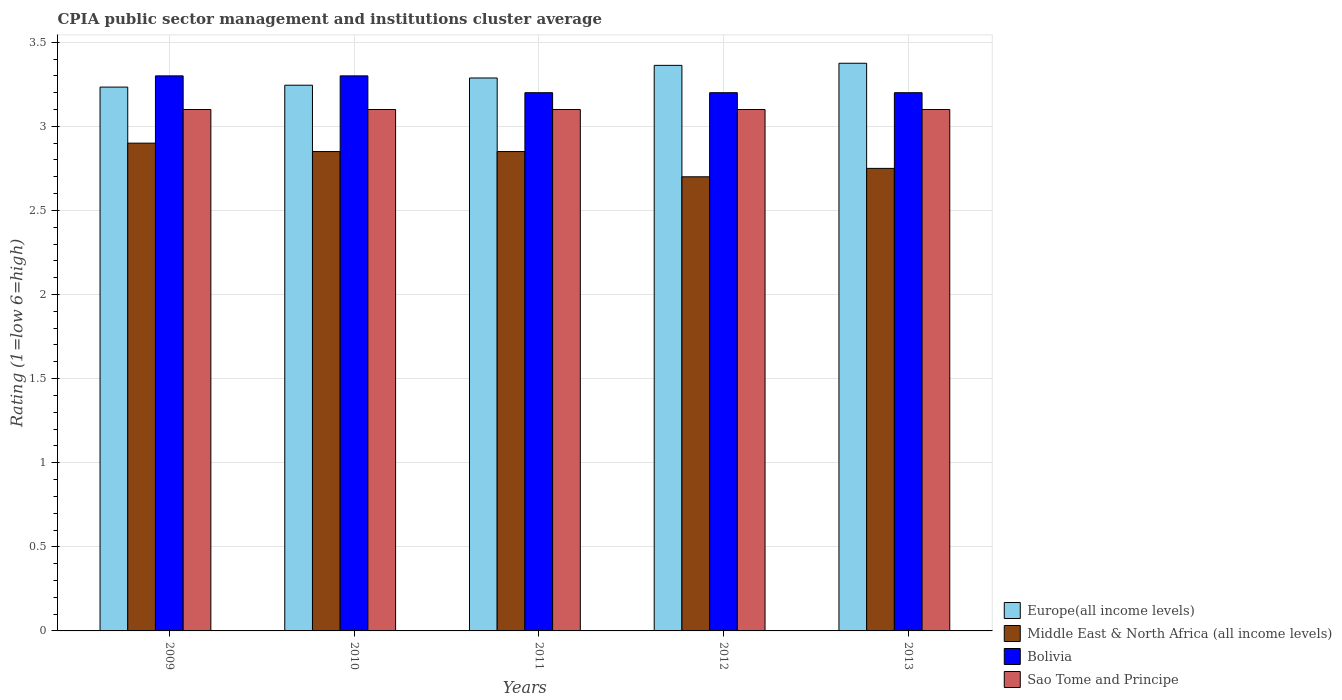How many different coloured bars are there?
Ensure brevity in your answer.  4. How many bars are there on the 1st tick from the left?
Offer a very short reply. 4. How many bars are there on the 5th tick from the right?
Give a very brief answer. 4. In how many cases, is the number of bars for a given year not equal to the number of legend labels?
Your answer should be very brief. 0. What is the CPIA rating in Middle East & North Africa (all income levels) in 2013?
Your answer should be very brief. 2.75. What is the total CPIA rating in Europe(all income levels) in the graph?
Your answer should be very brief. 16.5. What is the difference between the CPIA rating in Sao Tome and Principe in 2009 and that in 2012?
Keep it short and to the point. 0. What is the difference between the CPIA rating in Sao Tome and Principe in 2011 and the CPIA rating in Europe(all income levels) in 2012?
Make the answer very short. -0.26. What is the average CPIA rating in Europe(all income levels) per year?
Ensure brevity in your answer.  3.3. In the year 2009, what is the difference between the CPIA rating in Europe(all income levels) and CPIA rating in Middle East & North Africa (all income levels)?
Offer a terse response. 0.33. In how many years, is the CPIA rating in Sao Tome and Principe greater than 2.9?
Provide a short and direct response. 5. What is the ratio of the CPIA rating in Middle East & North Africa (all income levels) in 2010 to that in 2012?
Provide a succinct answer. 1.06. Is the difference between the CPIA rating in Europe(all income levels) in 2011 and 2012 greater than the difference between the CPIA rating in Middle East & North Africa (all income levels) in 2011 and 2012?
Provide a short and direct response. No. What is the difference between the highest and the lowest CPIA rating in Europe(all income levels)?
Provide a short and direct response. 0.14. In how many years, is the CPIA rating in Middle East & North Africa (all income levels) greater than the average CPIA rating in Middle East & North Africa (all income levels) taken over all years?
Give a very brief answer. 3. Is the sum of the CPIA rating in Middle East & North Africa (all income levels) in 2009 and 2012 greater than the maximum CPIA rating in Bolivia across all years?
Your response must be concise. Yes. What does the 4th bar from the left in 2012 represents?
Make the answer very short. Sao Tome and Principe. What does the 1st bar from the right in 2011 represents?
Make the answer very short. Sao Tome and Principe. How many bars are there?
Provide a short and direct response. 20. Are all the bars in the graph horizontal?
Provide a succinct answer. No. What is the difference between two consecutive major ticks on the Y-axis?
Your answer should be very brief. 0.5. Does the graph contain any zero values?
Provide a succinct answer. No. Does the graph contain grids?
Offer a terse response. Yes. Where does the legend appear in the graph?
Make the answer very short. Bottom right. How many legend labels are there?
Your answer should be compact. 4. What is the title of the graph?
Your answer should be very brief. CPIA public sector management and institutions cluster average. Does "Paraguay" appear as one of the legend labels in the graph?
Ensure brevity in your answer.  No. What is the label or title of the Y-axis?
Give a very brief answer. Rating (1=low 6=high). What is the Rating (1=low 6=high) in Europe(all income levels) in 2009?
Offer a terse response. 3.23. What is the Rating (1=low 6=high) of Bolivia in 2009?
Keep it short and to the point. 3.3. What is the Rating (1=low 6=high) in Europe(all income levels) in 2010?
Make the answer very short. 3.24. What is the Rating (1=low 6=high) of Middle East & North Africa (all income levels) in 2010?
Give a very brief answer. 2.85. What is the Rating (1=low 6=high) of Europe(all income levels) in 2011?
Provide a short and direct response. 3.29. What is the Rating (1=low 6=high) of Middle East & North Africa (all income levels) in 2011?
Provide a short and direct response. 2.85. What is the Rating (1=low 6=high) in Bolivia in 2011?
Your answer should be compact. 3.2. What is the Rating (1=low 6=high) in Europe(all income levels) in 2012?
Make the answer very short. 3.36. What is the Rating (1=low 6=high) of Middle East & North Africa (all income levels) in 2012?
Your response must be concise. 2.7. What is the Rating (1=low 6=high) of Sao Tome and Principe in 2012?
Ensure brevity in your answer.  3.1. What is the Rating (1=low 6=high) of Europe(all income levels) in 2013?
Your answer should be very brief. 3.38. What is the Rating (1=low 6=high) of Middle East & North Africa (all income levels) in 2013?
Make the answer very short. 2.75. What is the Rating (1=low 6=high) of Sao Tome and Principe in 2013?
Your response must be concise. 3.1. Across all years, what is the maximum Rating (1=low 6=high) in Europe(all income levels)?
Give a very brief answer. 3.38. Across all years, what is the maximum Rating (1=low 6=high) of Middle East & North Africa (all income levels)?
Offer a very short reply. 2.9. Across all years, what is the minimum Rating (1=low 6=high) of Europe(all income levels)?
Give a very brief answer. 3.23. What is the total Rating (1=low 6=high) in Europe(all income levels) in the graph?
Offer a terse response. 16.5. What is the total Rating (1=low 6=high) in Middle East & North Africa (all income levels) in the graph?
Offer a terse response. 14.05. What is the total Rating (1=low 6=high) of Sao Tome and Principe in the graph?
Provide a short and direct response. 15.5. What is the difference between the Rating (1=low 6=high) of Europe(all income levels) in 2009 and that in 2010?
Your response must be concise. -0.01. What is the difference between the Rating (1=low 6=high) of Middle East & North Africa (all income levels) in 2009 and that in 2010?
Provide a short and direct response. 0.05. What is the difference between the Rating (1=low 6=high) of Bolivia in 2009 and that in 2010?
Keep it short and to the point. 0. What is the difference between the Rating (1=low 6=high) in Sao Tome and Principe in 2009 and that in 2010?
Provide a short and direct response. 0. What is the difference between the Rating (1=low 6=high) of Europe(all income levels) in 2009 and that in 2011?
Make the answer very short. -0.05. What is the difference between the Rating (1=low 6=high) in Middle East & North Africa (all income levels) in 2009 and that in 2011?
Give a very brief answer. 0.05. What is the difference between the Rating (1=low 6=high) in Europe(all income levels) in 2009 and that in 2012?
Your response must be concise. -0.13. What is the difference between the Rating (1=low 6=high) of Bolivia in 2009 and that in 2012?
Make the answer very short. 0.1. What is the difference between the Rating (1=low 6=high) in Europe(all income levels) in 2009 and that in 2013?
Provide a short and direct response. -0.14. What is the difference between the Rating (1=low 6=high) of Middle East & North Africa (all income levels) in 2009 and that in 2013?
Provide a short and direct response. 0.15. What is the difference between the Rating (1=low 6=high) in Sao Tome and Principe in 2009 and that in 2013?
Ensure brevity in your answer.  0. What is the difference between the Rating (1=low 6=high) in Europe(all income levels) in 2010 and that in 2011?
Your response must be concise. -0.04. What is the difference between the Rating (1=low 6=high) of Bolivia in 2010 and that in 2011?
Your response must be concise. 0.1. What is the difference between the Rating (1=low 6=high) of Europe(all income levels) in 2010 and that in 2012?
Your answer should be very brief. -0.12. What is the difference between the Rating (1=low 6=high) in Middle East & North Africa (all income levels) in 2010 and that in 2012?
Offer a terse response. 0.15. What is the difference between the Rating (1=low 6=high) in Europe(all income levels) in 2010 and that in 2013?
Provide a short and direct response. -0.13. What is the difference between the Rating (1=low 6=high) of Middle East & North Africa (all income levels) in 2010 and that in 2013?
Make the answer very short. 0.1. What is the difference between the Rating (1=low 6=high) in Europe(all income levels) in 2011 and that in 2012?
Provide a succinct answer. -0.07. What is the difference between the Rating (1=low 6=high) in Bolivia in 2011 and that in 2012?
Your answer should be compact. 0. What is the difference between the Rating (1=low 6=high) in Europe(all income levels) in 2011 and that in 2013?
Keep it short and to the point. -0.09. What is the difference between the Rating (1=low 6=high) of Middle East & North Africa (all income levels) in 2011 and that in 2013?
Give a very brief answer. 0.1. What is the difference between the Rating (1=low 6=high) of Bolivia in 2011 and that in 2013?
Your answer should be very brief. 0. What is the difference between the Rating (1=low 6=high) in Europe(all income levels) in 2012 and that in 2013?
Offer a very short reply. -0.01. What is the difference between the Rating (1=low 6=high) of Middle East & North Africa (all income levels) in 2012 and that in 2013?
Your response must be concise. -0.05. What is the difference between the Rating (1=low 6=high) of Sao Tome and Principe in 2012 and that in 2013?
Make the answer very short. 0. What is the difference between the Rating (1=low 6=high) of Europe(all income levels) in 2009 and the Rating (1=low 6=high) of Middle East & North Africa (all income levels) in 2010?
Make the answer very short. 0.38. What is the difference between the Rating (1=low 6=high) in Europe(all income levels) in 2009 and the Rating (1=low 6=high) in Bolivia in 2010?
Keep it short and to the point. -0.07. What is the difference between the Rating (1=low 6=high) in Europe(all income levels) in 2009 and the Rating (1=low 6=high) in Sao Tome and Principe in 2010?
Give a very brief answer. 0.13. What is the difference between the Rating (1=low 6=high) in Middle East & North Africa (all income levels) in 2009 and the Rating (1=low 6=high) in Bolivia in 2010?
Provide a succinct answer. -0.4. What is the difference between the Rating (1=low 6=high) of Europe(all income levels) in 2009 and the Rating (1=low 6=high) of Middle East & North Africa (all income levels) in 2011?
Your answer should be very brief. 0.38. What is the difference between the Rating (1=low 6=high) of Europe(all income levels) in 2009 and the Rating (1=low 6=high) of Bolivia in 2011?
Ensure brevity in your answer.  0.03. What is the difference between the Rating (1=low 6=high) of Europe(all income levels) in 2009 and the Rating (1=low 6=high) of Sao Tome and Principe in 2011?
Ensure brevity in your answer.  0.13. What is the difference between the Rating (1=low 6=high) in Middle East & North Africa (all income levels) in 2009 and the Rating (1=low 6=high) in Bolivia in 2011?
Your answer should be compact. -0.3. What is the difference between the Rating (1=low 6=high) of Europe(all income levels) in 2009 and the Rating (1=low 6=high) of Middle East & North Africa (all income levels) in 2012?
Keep it short and to the point. 0.53. What is the difference between the Rating (1=low 6=high) in Europe(all income levels) in 2009 and the Rating (1=low 6=high) in Sao Tome and Principe in 2012?
Provide a succinct answer. 0.13. What is the difference between the Rating (1=low 6=high) in Bolivia in 2009 and the Rating (1=low 6=high) in Sao Tome and Principe in 2012?
Provide a short and direct response. 0.2. What is the difference between the Rating (1=low 6=high) of Europe(all income levels) in 2009 and the Rating (1=low 6=high) of Middle East & North Africa (all income levels) in 2013?
Offer a terse response. 0.48. What is the difference between the Rating (1=low 6=high) in Europe(all income levels) in 2009 and the Rating (1=low 6=high) in Sao Tome and Principe in 2013?
Offer a terse response. 0.13. What is the difference between the Rating (1=low 6=high) in Bolivia in 2009 and the Rating (1=low 6=high) in Sao Tome and Principe in 2013?
Give a very brief answer. 0.2. What is the difference between the Rating (1=low 6=high) in Europe(all income levels) in 2010 and the Rating (1=low 6=high) in Middle East & North Africa (all income levels) in 2011?
Offer a terse response. 0.39. What is the difference between the Rating (1=low 6=high) of Europe(all income levels) in 2010 and the Rating (1=low 6=high) of Bolivia in 2011?
Your response must be concise. 0.04. What is the difference between the Rating (1=low 6=high) of Europe(all income levels) in 2010 and the Rating (1=low 6=high) of Sao Tome and Principe in 2011?
Keep it short and to the point. 0.14. What is the difference between the Rating (1=low 6=high) in Middle East & North Africa (all income levels) in 2010 and the Rating (1=low 6=high) in Bolivia in 2011?
Give a very brief answer. -0.35. What is the difference between the Rating (1=low 6=high) of Middle East & North Africa (all income levels) in 2010 and the Rating (1=low 6=high) of Sao Tome and Principe in 2011?
Offer a terse response. -0.25. What is the difference between the Rating (1=low 6=high) in Europe(all income levels) in 2010 and the Rating (1=low 6=high) in Middle East & North Africa (all income levels) in 2012?
Ensure brevity in your answer.  0.54. What is the difference between the Rating (1=low 6=high) in Europe(all income levels) in 2010 and the Rating (1=low 6=high) in Bolivia in 2012?
Your response must be concise. 0.04. What is the difference between the Rating (1=low 6=high) in Europe(all income levels) in 2010 and the Rating (1=low 6=high) in Sao Tome and Principe in 2012?
Offer a terse response. 0.14. What is the difference between the Rating (1=low 6=high) in Middle East & North Africa (all income levels) in 2010 and the Rating (1=low 6=high) in Bolivia in 2012?
Offer a very short reply. -0.35. What is the difference between the Rating (1=low 6=high) in Middle East & North Africa (all income levels) in 2010 and the Rating (1=low 6=high) in Sao Tome and Principe in 2012?
Keep it short and to the point. -0.25. What is the difference between the Rating (1=low 6=high) in Europe(all income levels) in 2010 and the Rating (1=low 6=high) in Middle East & North Africa (all income levels) in 2013?
Keep it short and to the point. 0.49. What is the difference between the Rating (1=low 6=high) in Europe(all income levels) in 2010 and the Rating (1=low 6=high) in Bolivia in 2013?
Provide a succinct answer. 0.04. What is the difference between the Rating (1=low 6=high) in Europe(all income levels) in 2010 and the Rating (1=low 6=high) in Sao Tome and Principe in 2013?
Your answer should be very brief. 0.14. What is the difference between the Rating (1=low 6=high) of Middle East & North Africa (all income levels) in 2010 and the Rating (1=low 6=high) of Bolivia in 2013?
Provide a succinct answer. -0.35. What is the difference between the Rating (1=low 6=high) in Middle East & North Africa (all income levels) in 2010 and the Rating (1=low 6=high) in Sao Tome and Principe in 2013?
Offer a very short reply. -0.25. What is the difference between the Rating (1=low 6=high) of Europe(all income levels) in 2011 and the Rating (1=low 6=high) of Middle East & North Africa (all income levels) in 2012?
Offer a very short reply. 0.59. What is the difference between the Rating (1=low 6=high) in Europe(all income levels) in 2011 and the Rating (1=low 6=high) in Bolivia in 2012?
Your response must be concise. 0.09. What is the difference between the Rating (1=low 6=high) of Europe(all income levels) in 2011 and the Rating (1=low 6=high) of Sao Tome and Principe in 2012?
Keep it short and to the point. 0.19. What is the difference between the Rating (1=low 6=high) in Middle East & North Africa (all income levels) in 2011 and the Rating (1=low 6=high) in Bolivia in 2012?
Provide a succinct answer. -0.35. What is the difference between the Rating (1=low 6=high) in Bolivia in 2011 and the Rating (1=low 6=high) in Sao Tome and Principe in 2012?
Keep it short and to the point. 0.1. What is the difference between the Rating (1=low 6=high) in Europe(all income levels) in 2011 and the Rating (1=low 6=high) in Middle East & North Africa (all income levels) in 2013?
Provide a succinct answer. 0.54. What is the difference between the Rating (1=low 6=high) in Europe(all income levels) in 2011 and the Rating (1=low 6=high) in Bolivia in 2013?
Give a very brief answer. 0.09. What is the difference between the Rating (1=low 6=high) in Europe(all income levels) in 2011 and the Rating (1=low 6=high) in Sao Tome and Principe in 2013?
Your answer should be compact. 0.19. What is the difference between the Rating (1=low 6=high) in Middle East & North Africa (all income levels) in 2011 and the Rating (1=low 6=high) in Bolivia in 2013?
Your response must be concise. -0.35. What is the difference between the Rating (1=low 6=high) of Europe(all income levels) in 2012 and the Rating (1=low 6=high) of Middle East & North Africa (all income levels) in 2013?
Keep it short and to the point. 0.61. What is the difference between the Rating (1=low 6=high) in Europe(all income levels) in 2012 and the Rating (1=low 6=high) in Bolivia in 2013?
Provide a short and direct response. 0.16. What is the difference between the Rating (1=low 6=high) of Europe(all income levels) in 2012 and the Rating (1=low 6=high) of Sao Tome and Principe in 2013?
Your answer should be compact. 0.26. What is the difference between the Rating (1=low 6=high) in Middle East & North Africa (all income levels) in 2012 and the Rating (1=low 6=high) in Bolivia in 2013?
Provide a short and direct response. -0.5. What is the difference between the Rating (1=low 6=high) in Middle East & North Africa (all income levels) in 2012 and the Rating (1=low 6=high) in Sao Tome and Principe in 2013?
Your answer should be compact. -0.4. What is the difference between the Rating (1=low 6=high) of Bolivia in 2012 and the Rating (1=low 6=high) of Sao Tome and Principe in 2013?
Offer a terse response. 0.1. What is the average Rating (1=low 6=high) in Europe(all income levels) per year?
Offer a terse response. 3.3. What is the average Rating (1=low 6=high) of Middle East & North Africa (all income levels) per year?
Ensure brevity in your answer.  2.81. What is the average Rating (1=low 6=high) in Bolivia per year?
Provide a short and direct response. 3.24. In the year 2009, what is the difference between the Rating (1=low 6=high) of Europe(all income levels) and Rating (1=low 6=high) of Bolivia?
Provide a short and direct response. -0.07. In the year 2009, what is the difference between the Rating (1=low 6=high) of Europe(all income levels) and Rating (1=low 6=high) of Sao Tome and Principe?
Make the answer very short. 0.13. In the year 2009, what is the difference between the Rating (1=low 6=high) in Middle East & North Africa (all income levels) and Rating (1=low 6=high) in Bolivia?
Offer a very short reply. -0.4. In the year 2009, what is the difference between the Rating (1=low 6=high) in Bolivia and Rating (1=low 6=high) in Sao Tome and Principe?
Ensure brevity in your answer.  0.2. In the year 2010, what is the difference between the Rating (1=low 6=high) of Europe(all income levels) and Rating (1=low 6=high) of Middle East & North Africa (all income levels)?
Offer a terse response. 0.39. In the year 2010, what is the difference between the Rating (1=low 6=high) in Europe(all income levels) and Rating (1=low 6=high) in Bolivia?
Offer a very short reply. -0.06. In the year 2010, what is the difference between the Rating (1=low 6=high) in Europe(all income levels) and Rating (1=low 6=high) in Sao Tome and Principe?
Make the answer very short. 0.14. In the year 2010, what is the difference between the Rating (1=low 6=high) of Middle East & North Africa (all income levels) and Rating (1=low 6=high) of Bolivia?
Ensure brevity in your answer.  -0.45. In the year 2011, what is the difference between the Rating (1=low 6=high) of Europe(all income levels) and Rating (1=low 6=high) of Middle East & North Africa (all income levels)?
Keep it short and to the point. 0.44. In the year 2011, what is the difference between the Rating (1=low 6=high) in Europe(all income levels) and Rating (1=low 6=high) in Bolivia?
Your response must be concise. 0.09. In the year 2011, what is the difference between the Rating (1=low 6=high) of Europe(all income levels) and Rating (1=low 6=high) of Sao Tome and Principe?
Your answer should be very brief. 0.19. In the year 2011, what is the difference between the Rating (1=low 6=high) in Middle East & North Africa (all income levels) and Rating (1=low 6=high) in Bolivia?
Provide a succinct answer. -0.35. In the year 2011, what is the difference between the Rating (1=low 6=high) in Middle East & North Africa (all income levels) and Rating (1=low 6=high) in Sao Tome and Principe?
Offer a terse response. -0.25. In the year 2011, what is the difference between the Rating (1=low 6=high) in Bolivia and Rating (1=low 6=high) in Sao Tome and Principe?
Your answer should be very brief. 0.1. In the year 2012, what is the difference between the Rating (1=low 6=high) of Europe(all income levels) and Rating (1=low 6=high) of Middle East & North Africa (all income levels)?
Offer a terse response. 0.66. In the year 2012, what is the difference between the Rating (1=low 6=high) of Europe(all income levels) and Rating (1=low 6=high) of Bolivia?
Ensure brevity in your answer.  0.16. In the year 2012, what is the difference between the Rating (1=low 6=high) of Europe(all income levels) and Rating (1=low 6=high) of Sao Tome and Principe?
Your response must be concise. 0.26. In the year 2012, what is the difference between the Rating (1=low 6=high) in Bolivia and Rating (1=low 6=high) in Sao Tome and Principe?
Offer a very short reply. 0.1. In the year 2013, what is the difference between the Rating (1=low 6=high) of Europe(all income levels) and Rating (1=low 6=high) of Bolivia?
Provide a short and direct response. 0.17. In the year 2013, what is the difference between the Rating (1=low 6=high) of Europe(all income levels) and Rating (1=low 6=high) of Sao Tome and Principe?
Ensure brevity in your answer.  0.28. In the year 2013, what is the difference between the Rating (1=low 6=high) in Middle East & North Africa (all income levels) and Rating (1=low 6=high) in Bolivia?
Give a very brief answer. -0.45. In the year 2013, what is the difference between the Rating (1=low 6=high) in Middle East & North Africa (all income levels) and Rating (1=low 6=high) in Sao Tome and Principe?
Give a very brief answer. -0.35. What is the ratio of the Rating (1=low 6=high) in Middle East & North Africa (all income levels) in 2009 to that in 2010?
Provide a succinct answer. 1.02. What is the ratio of the Rating (1=low 6=high) of Bolivia in 2009 to that in 2010?
Give a very brief answer. 1. What is the ratio of the Rating (1=low 6=high) of Sao Tome and Principe in 2009 to that in 2010?
Your answer should be compact. 1. What is the ratio of the Rating (1=low 6=high) in Europe(all income levels) in 2009 to that in 2011?
Your answer should be compact. 0.98. What is the ratio of the Rating (1=low 6=high) in Middle East & North Africa (all income levels) in 2009 to that in 2011?
Give a very brief answer. 1.02. What is the ratio of the Rating (1=low 6=high) in Bolivia in 2009 to that in 2011?
Your answer should be compact. 1.03. What is the ratio of the Rating (1=low 6=high) in Sao Tome and Principe in 2009 to that in 2011?
Your response must be concise. 1. What is the ratio of the Rating (1=low 6=high) in Europe(all income levels) in 2009 to that in 2012?
Offer a very short reply. 0.96. What is the ratio of the Rating (1=low 6=high) of Middle East & North Africa (all income levels) in 2009 to that in 2012?
Offer a terse response. 1.07. What is the ratio of the Rating (1=low 6=high) in Bolivia in 2009 to that in 2012?
Give a very brief answer. 1.03. What is the ratio of the Rating (1=low 6=high) in Europe(all income levels) in 2009 to that in 2013?
Ensure brevity in your answer.  0.96. What is the ratio of the Rating (1=low 6=high) of Middle East & North Africa (all income levels) in 2009 to that in 2013?
Your answer should be compact. 1.05. What is the ratio of the Rating (1=low 6=high) in Bolivia in 2009 to that in 2013?
Your answer should be very brief. 1.03. What is the ratio of the Rating (1=low 6=high) of Sao Tome and Principe in 2009 to that in 2013?
Give a very brief answer. 1. What is the ratio of the Rating (1=low 6=high) of Europe(all income levels) in 2010 to that in 2011?
Give a very brief answer. 0.99. What is the ratio of the Rating (1=low 6=high) in Middle East & North Africa (all income levels) in 2010 to that in 2011?
Give a very brief answer. 1. What is the ratio of the Rating (1=low 6=high) in Bolivia in 2010 to that in 2011?
Give a very brief answer. 1.03. What is the ratio of the Rating (1=low 6=high) in Europe(all income levels) in 2010 to that in 2012?
Give a very brief answer. 0.96. What is the ratio of the Rating (1=low 6=high) of Middle East & North Africa (all income levels) in 2010 to that in 2012?
Your answer should be very brief. 1.06. What is the ratio of the Rating (1=low 6=high) in Bolivia in 2010 to that in 2012?
Offer a terse response. 1.03. What is the ratio of the Rating (1=low 6=high) in Europe(all income levels) in 2010 to that in 2013?
Offer a terse response. 0.96. What is the ratio of the Rating (1=low 6=high) in Middle East & North Africa (all income levels) in 2010 to that in 2013?
Your answer should be compact. 1.04. What is the ratio of the Rating (1=low 6=high) of Bolivia in 2010 to that in 2013?
Offer a very short reply. 1.03. What is the ratio of the Rating (1=low 6=high) of Sao Tome and Principe in 2010 to that in 2013?
Provide a short and direct response. 1. What is the ratio of the Rating (1=low 6=high) of Europe(all income levels) in 2011 to that in 2012?
Provide a short and direct response. 0.98. What is the ratio of the Rating (1=low 6=high) of Middle East & North Africa (all income levels) in 2011 to that in 2012?
Provide a succinct answer. 1.06. What is the ratio of the Rating (1=low 6=high) in Bolivia in 2011 to that in 2012?
Ensure brevity in your answer.  1. What is the ratio of the Rating (1=low 6=high) of Europe(all income levels) in 2011 to that in 2013?
Keep it short and to the point. 0.97. What is the ratio of the Rating (1=low 6=high) of Middle East & North Africa (all income levels) in 2011 to that in 2013?
Make the answer very short. 1.04. What is the ratio of the Rating (1=low 6=high) in Bolivia in 2011 to that in 2013?
Ensure brevity in your answer.  1. What is the ratio of the Rating (1=low 6=high) of Europe(all income levels) in 2012 to that in 2013?
Your response must be concise. 1. What is the ratio of the Rating (1=low 6=high) in Middle East & North Africa (all income levels) in 2012 to that in 2013?
Offer a terse response. 0.98. What is the ratio of the Rating (1=low 6=high) of Sao Tome and Principe in 2012 to that in 2013?
Your response must be concise. 1. What is the difference between the highest and the second highest Rating (1=low 6=high) in Europe(all income levels)?
Keep it short and to the point. 0.01. What is the difference between the highest and the second highest Rating (1=low 6=high) of Middle East & North Africa (all income levels)?
Give a very brief answer. 0.05. What is the difference between the highest and the second highest Rating (1=low 6=high) of Bolivia?
Your answer should be very brief. 0. What is the difference between the highest and the lowest Rating (1=low 6=high) in Europe(all income levels)?
Make the answer very short. 0.14. 